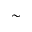<formula> <loc_0><loc_0><loc_500><loc_500>\sim</formula> 